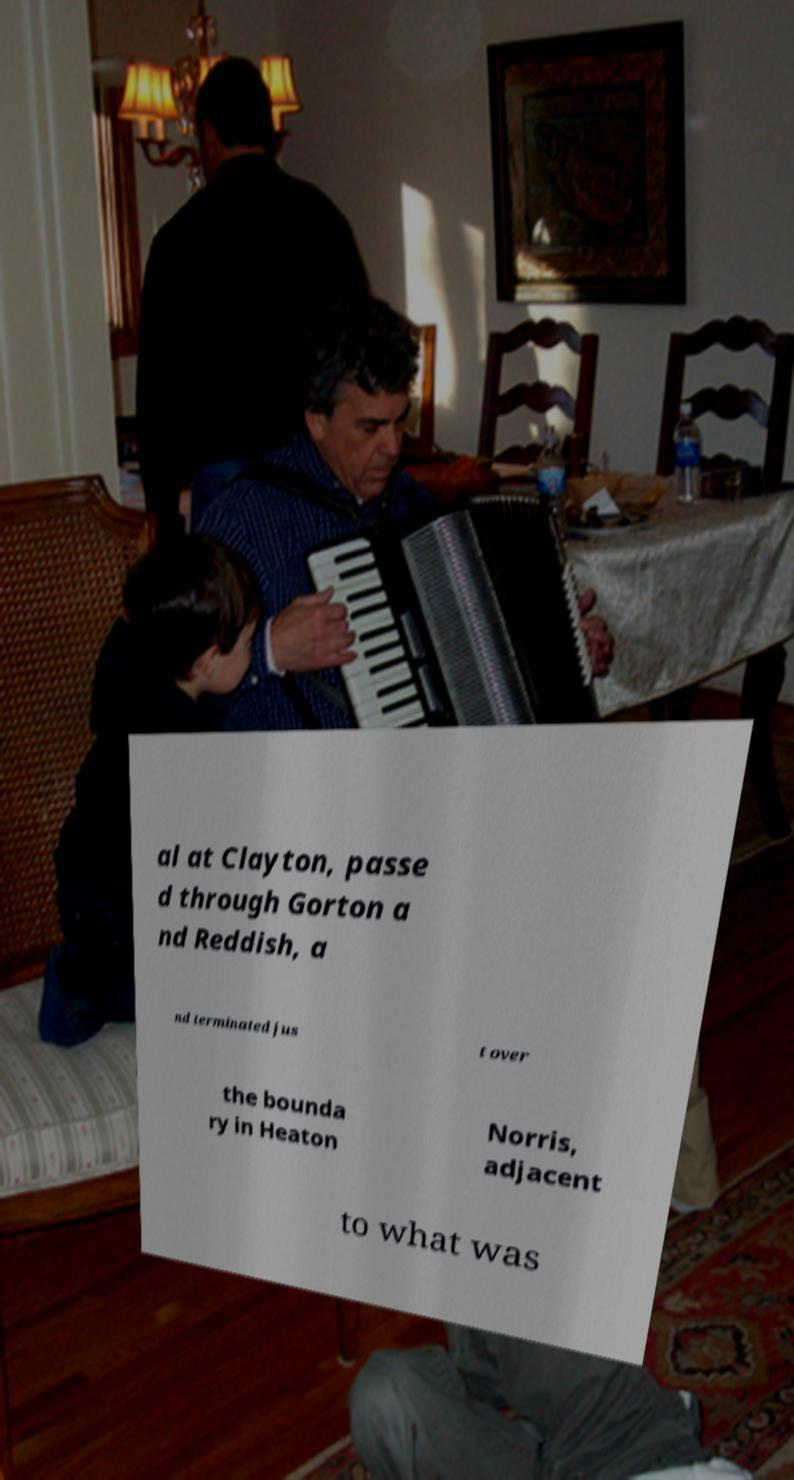Please read and relay the text visible in this image. What does it say? al at Clayton, passe d through Gorton a nd Reddish, a nd terminated jus t over the bounda ry in Heaton Norris, adjacent to what was 